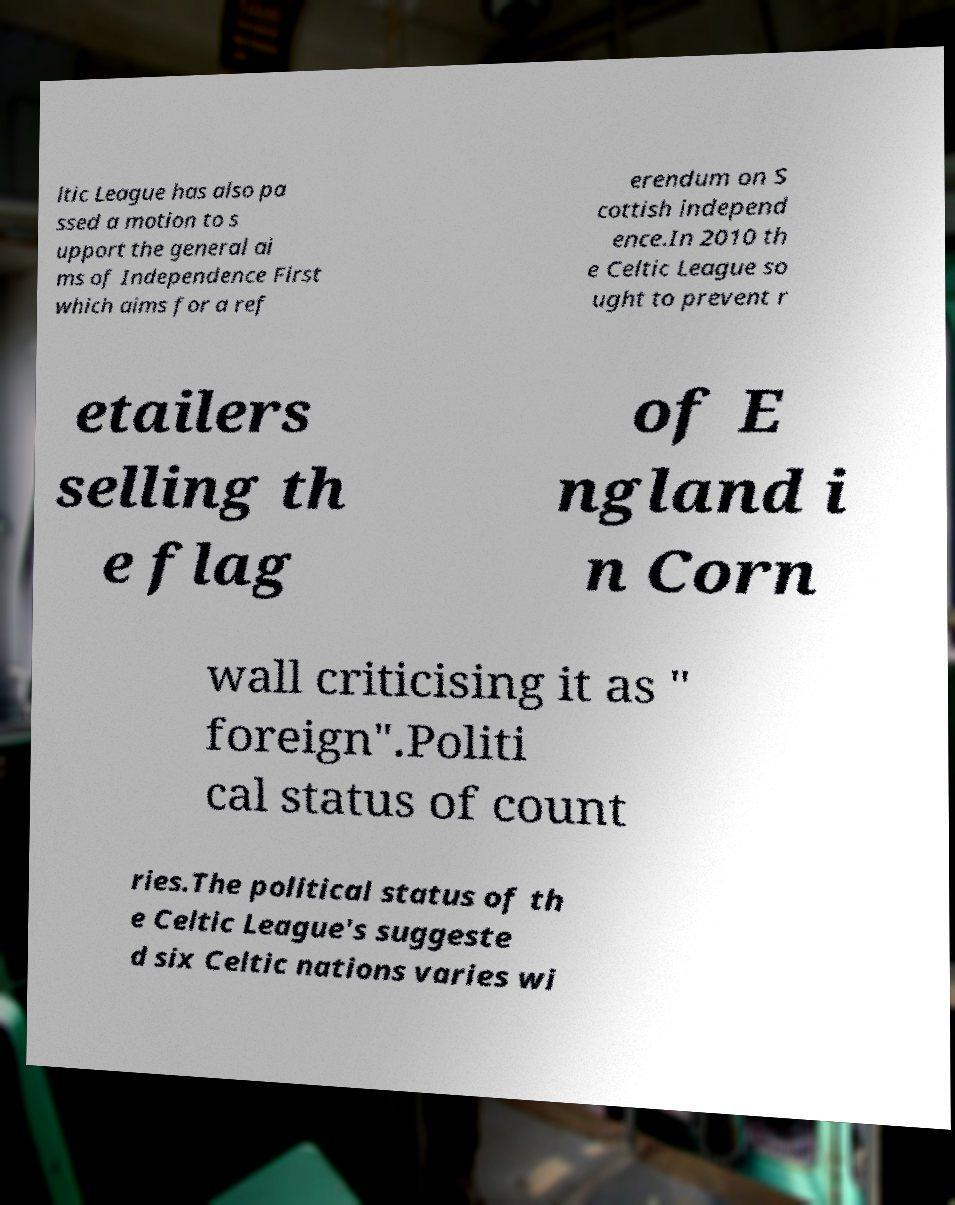Can you accurately transcribe the text from the provided image for me? ltic League has also pa ssed a motion to s upport the general ai ms of Independence First which aims for a ref erendum on S cottish independ ence.In 2010 th e Celtic League so ught to prevent r etailers selling th e flag of E ngland i n Corn wall criticising it as " foreign".Politi cal status of count ries.The political status of th e Celtic League's suggeste d six Celtic nations varies wi 